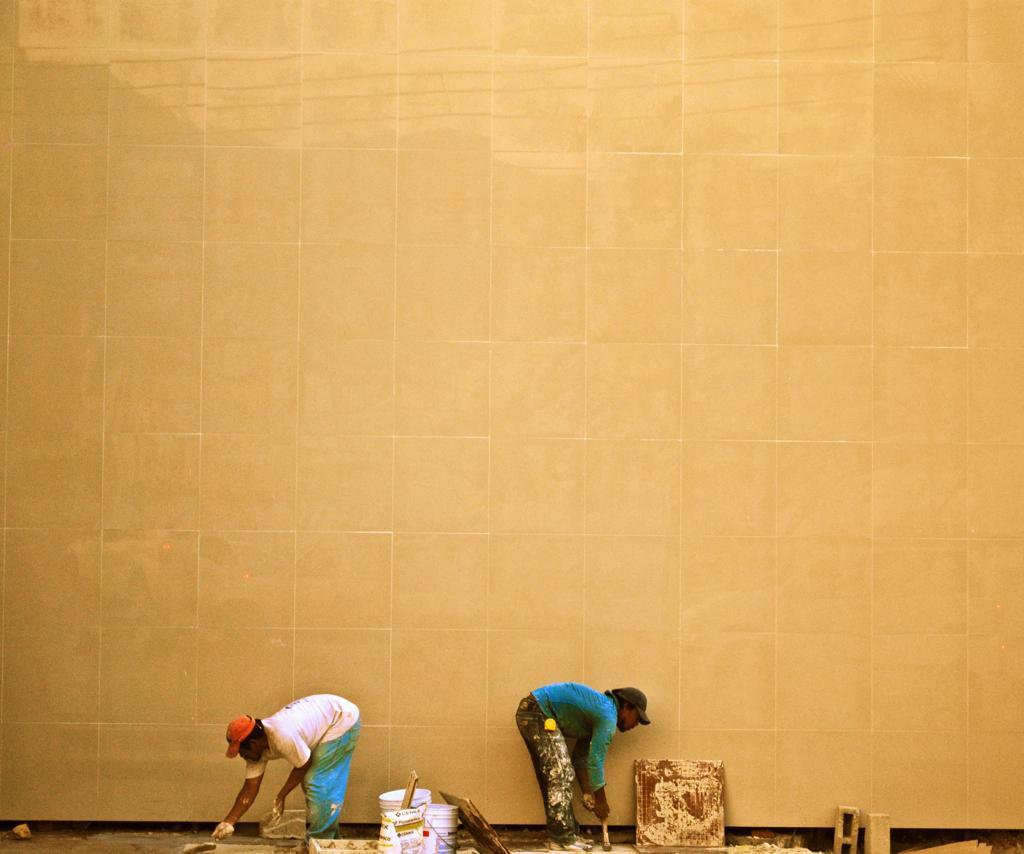How would you summarize this image in a sentence or two? The man in white T-shirt and blue pant is holding the paint brush in his hand. Behind him, the man in blue T-shirt is also holding the painting brush in his hand. In between them,we see paint boxes. Beside them, we see a wall. I think they are painting the wall. 